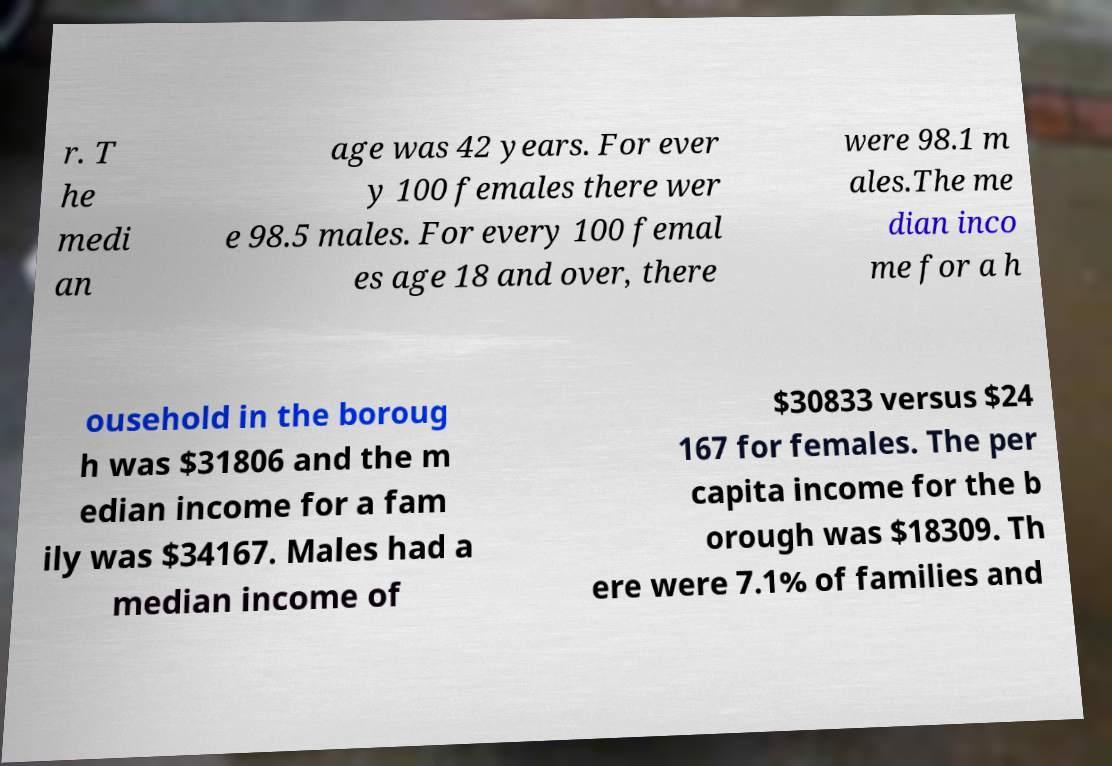Could you extract and type out the text from this image? r. T he medi an age was 42 years. For ever y 100 females there wer e 98.5 males. For every 100 femal es age 18 and over, there were 98.1 m ales.The me dian inco me for a h ousehold in the boroug h was $31806 and the m edian income for a fam ily was $34167. Males had a median income of $30833 versus $24 167 for females. The per capita income for the b orough was $18309. Th ere were 7.1% of families and 